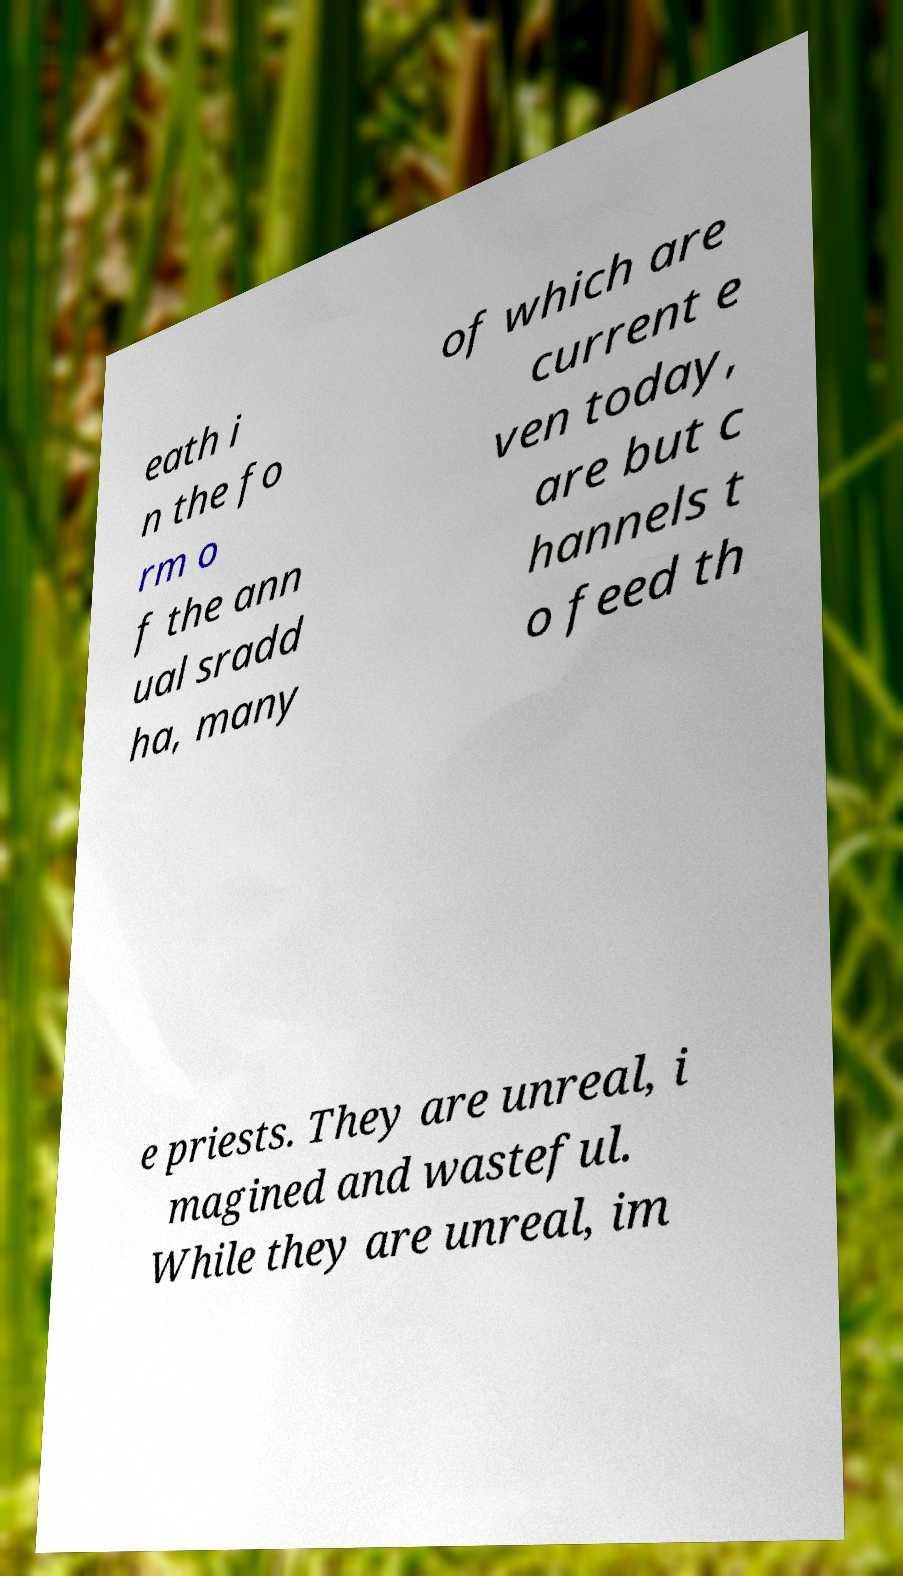Can you accurately transcribe the text from the provided image for me? eath i n the fo rm o f the ann ual sradd ha, many of which are current e ven today, are but c hannels t o feed th e priests. They are unreal, i magined and wasteful. While they are unreal, im 